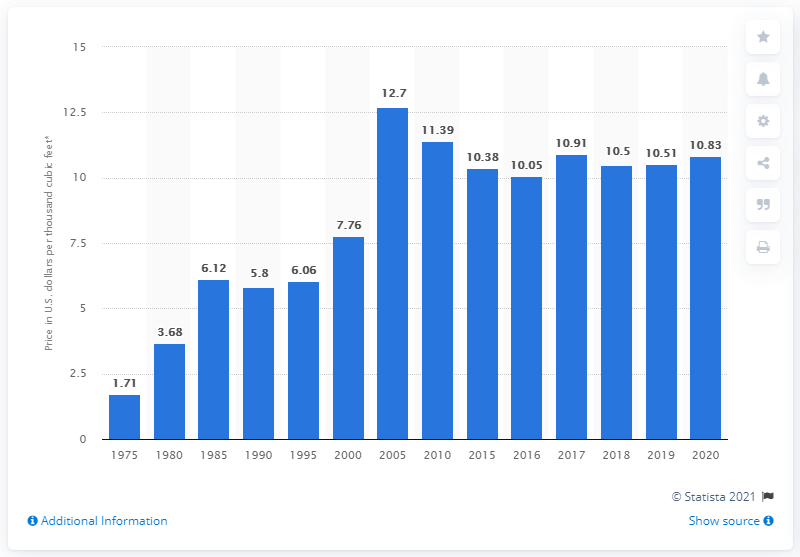Draw attention to some important aspects in this diagram. In the previous decade, the peak price of natural gas in the United States reached 12.7 dollars per unit. 